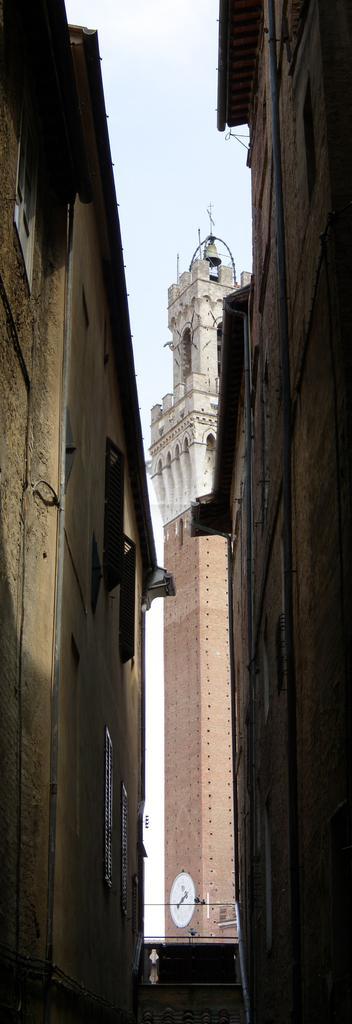Please provide a concise description of this image. In this picture we can see few buildings and a clock. 